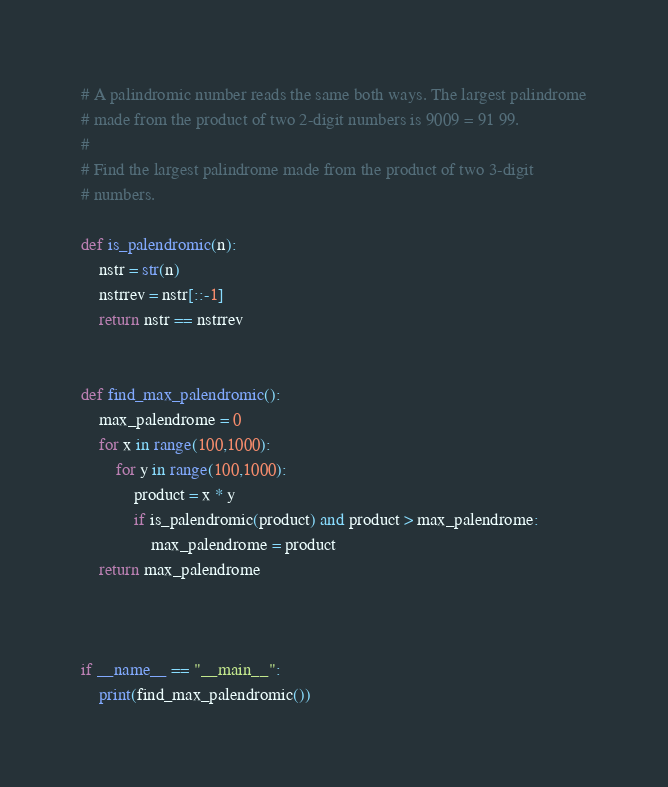<code> <loc_0><loc_0><loc_500><loc_500><_Python_># A palindromic number reads the same both ways. The largest palindrome
# made from the product of two 2-digit numbers is 9009 = 91 99.
#
# Find the largest palindrome made from the product of two 3-digit
# numbers.

def is_palendromic(n):
    nstr = str(n)
    nstrrev = nstr[::-1]
    return nstr == nstrrev


def find_max_palendromic():
    max_palendrome = 0
    for x in range(100,1000):
        for y in range(100,1000):
            product = x * y
            if is_palendromic(product) and product > max_palendrome:
                max_palendrome = product
    return max_palendrome



if __name__ == "__main__":
    print(find_max_palendromic())
</code> 